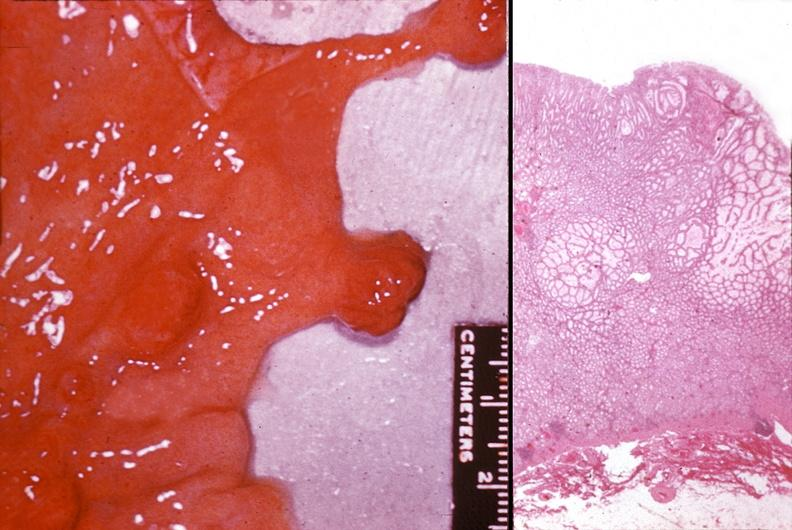does this image show stomach, polyposis, multiple?
Answer the question using a single word or phrase. Yes 